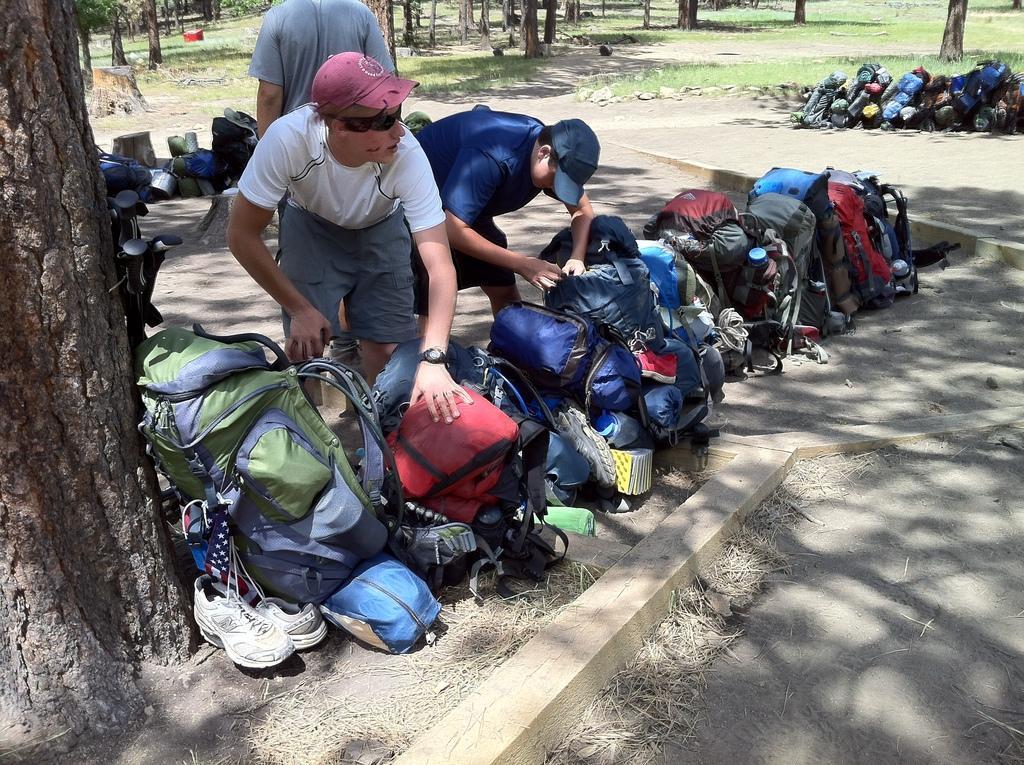In one or two sentences, can you explain what this image depicts? In this image we can see three men standing. We can also see some bags, shoes and some objects placed on the ground, the bark of the trees, stones and grass. 